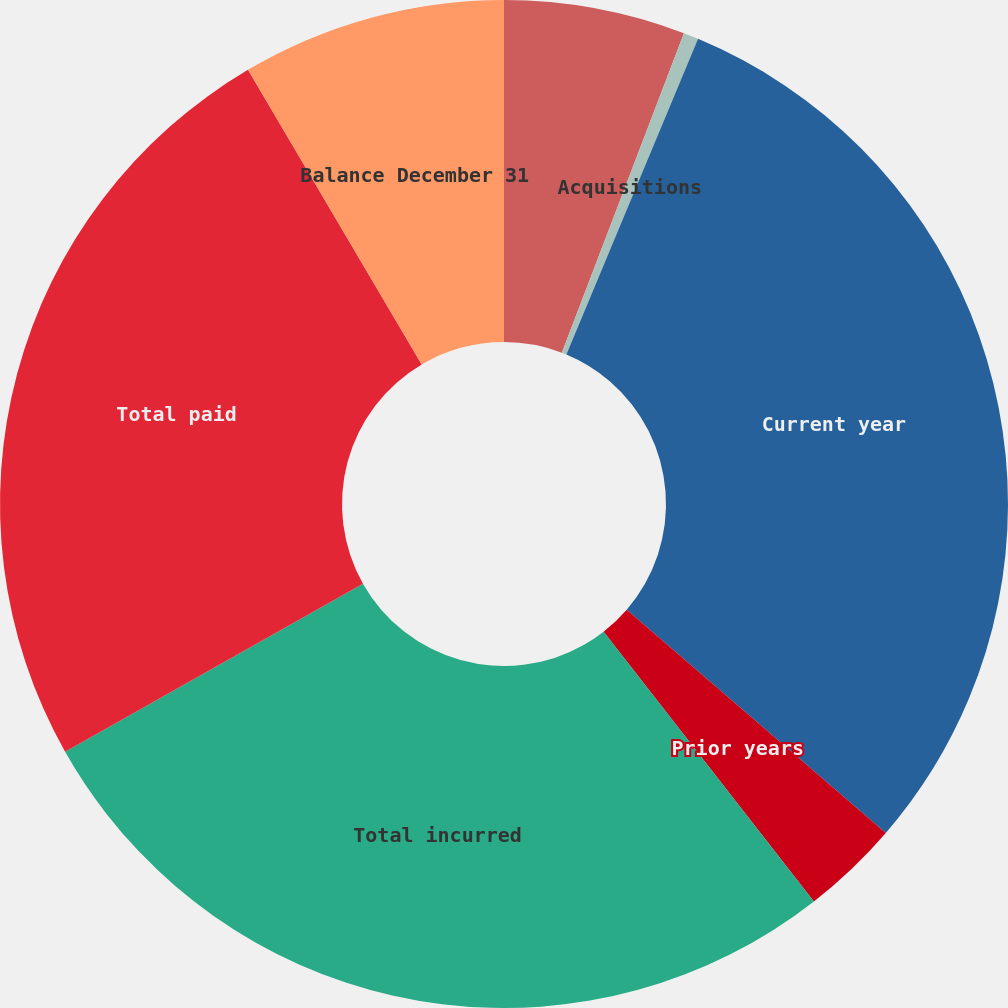Convert chart to OTSL. <chart><loc_0><loc_0><loc_500><loc_500><pie_chart><fcel>Balance January 1<fcel>Acquisitions<fcel>Current year<fcel>Prior years<fcel>Total incurred<fcel>Total paid<fcel>Balance December 31<nl><fcel>5.81%<fcel>0.48%<fcel>30.03%<fcel>3.14%<fcel>27.36%<fcel>24.7%<fcel>8.48%<nl></chart> 